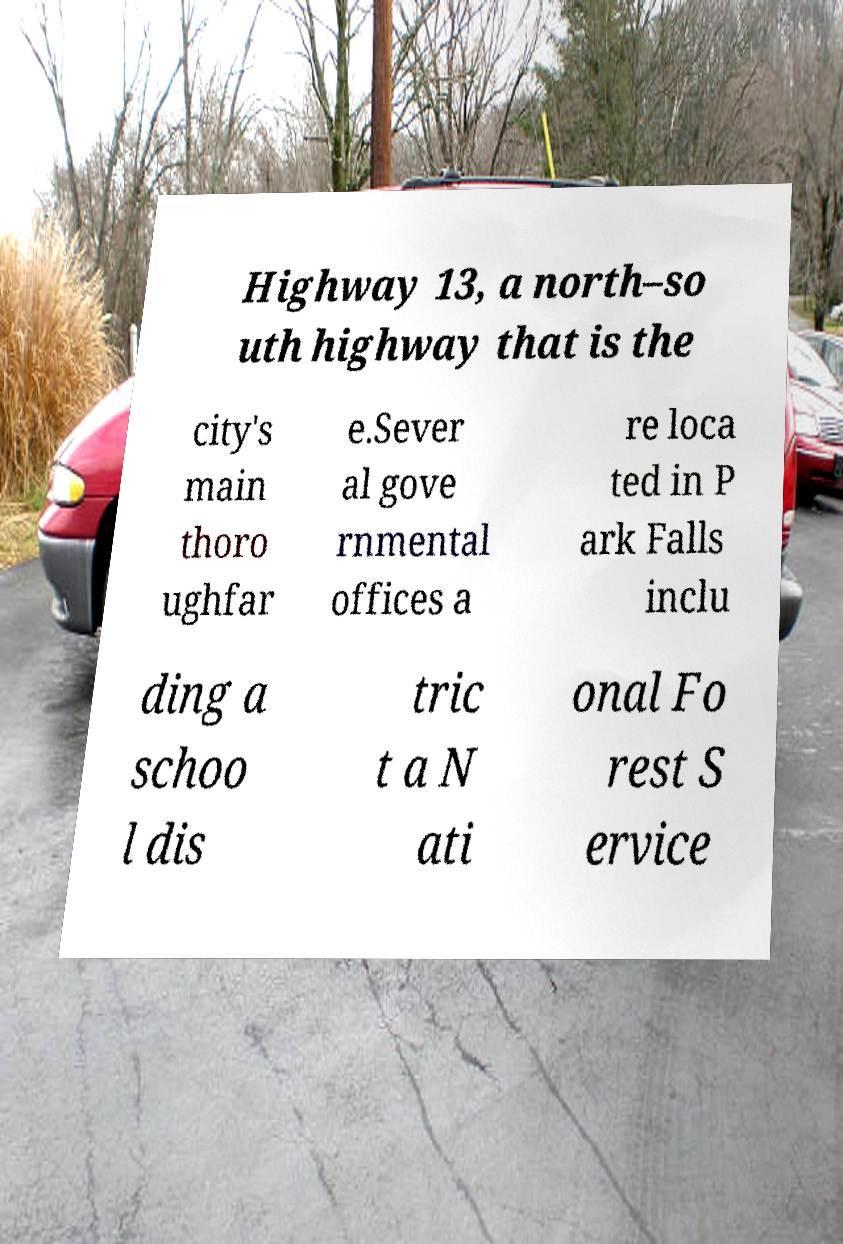I need the written content from this picture converted into text. Can you do that? Highway 13, a north–so uth highway that is the city's main thoro ughfar e.Sever al gove rnmental offices a re loca ted in P ark Falls inclu ding a schoo l dis tric t a N ati onal Fo rest S ervice 